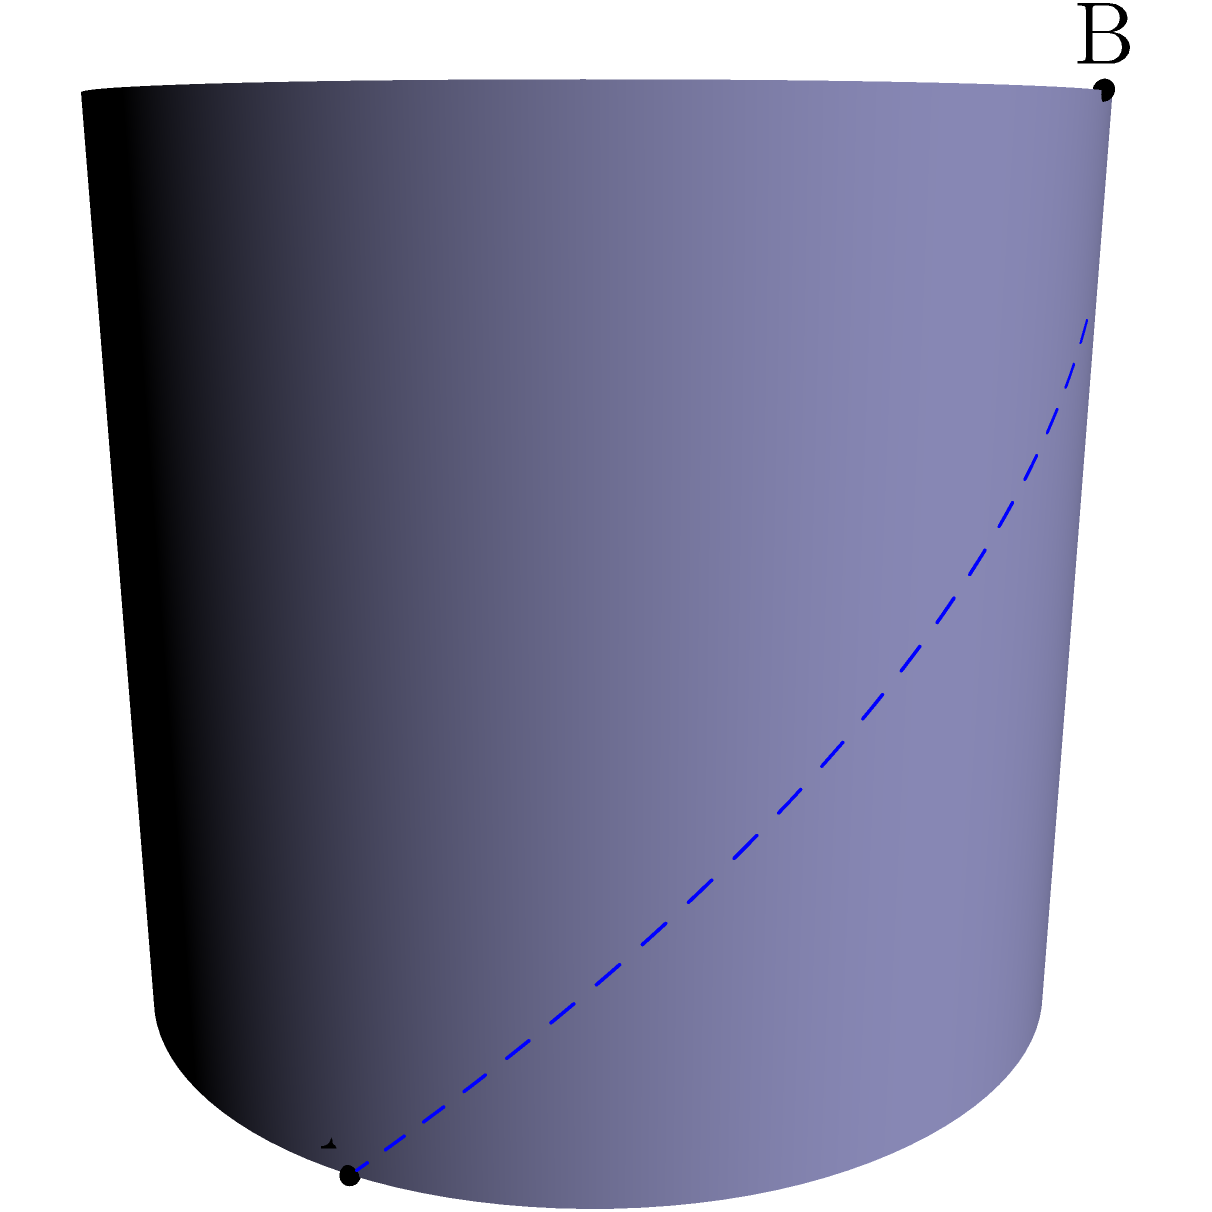As an executive funding AI research, you're presented with a problem in non-Euclidean geometry that has implications for optimizing neural network architectures. Consider a cylinder with radius 2 and points A(2,0,0) and B(0,2,2) on its surface. What is the ratio of the length of the shortest path (geodesic) between A and B on the cylinder's surface to the length of the straight line connecting A and B? To solve this problem, we need to follow these steps:

1) First, let's calculate the length of the straight line connecting A and B:
   $$d_{straight} = \sqrt{(2-0)^2 + (2-0)^2 + (2-0)^2} = \sqrt{12} = 2\sqrt{3}$$

2) Now, for the geodesic on the cylinder surface:
   - The path consists of an arc along the circle of the cylinder base and a vertical line segment.
   - The arc length is $2\theta$, where $\theta$ is the angle subtended at the center.
   - The vertical distance is 2 units.

3) To find $\theta$:
   $$\cos\theta = \frac{0}{2} = 0$$
   $$\theta = \frac{\pi}{2}$$

4) The length of the geodesic is:
   $$d_{geodesic} = \sqrt{(2\theta)^2 + 2^2} = \sqrt{(\pi)^2 + 4} = \sqrt{\pi^2 + 4}$$

5) The ratio we're looking for is:
   $$\frac{d_{geodesic}}{d_{straight}} = \frac{\sqrt{\pi^2 + 4}}{2\sqrt{3}}$$

This ratio demonstrates how the shortest path on a curved surface differs from the Euclidean straight line, a concept crucial in optimizing multi-dimensional spaces in AI algorithms.
Answer: $\frac{\sqrt{\pi^2 + 4}}{2\sqrt{3}}$ 